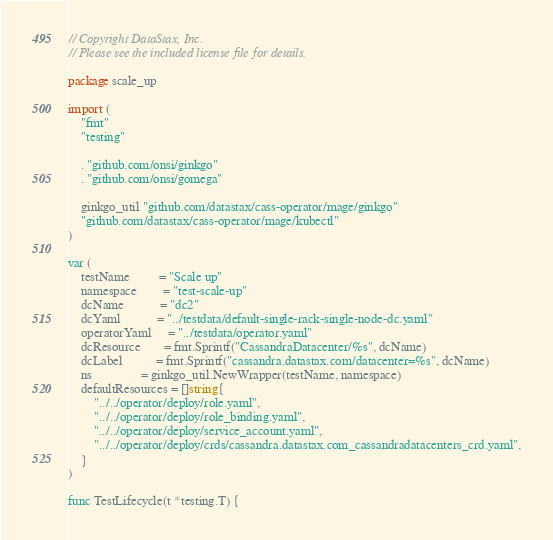Convert code to text. <code><loc_0><loc_0><loc_500><loc_500><_Go_>// Copyright DataStax, Inc.
// Please see the included license file for details.

package scale_up

import (
	"fmt"
	"testing"

	. "github.com/onsi/ginkgo"
	. "github.com/onsi/gomega"

	ginkgo_util "github.com/datastax/cass-operator/mage/ginkgo"
	"github.com/datastax/cass-operator/mage/kubectl"
)

var (
	testName         = "Scale up"
	namespace        = "test-scale-up"
	dcName           = "dc2"
	dcYaml           = "../testdata/default-single-rack-single-node-dc.yaml"
	operatorYaml     = "../testdata/operator.yaml"
	dcResource       = fmt.Sprintf("CassandraDatacenter/%s", dcName)
	dcLabel          = fmt.Sprintf("cassandra.datastax.com/datacenter=%s", dcName)
	ns               = ginkgo_util.NewWrapper(testName, namespace)
	defaultResources = []string{
		"../../operator/deploy/role.yaml",
		"../../operator/deploy/role_binding.yaml",
		"../../operator/deploy/service_account.yaml",
		"../../operator/deploy/crds/cassandra.datastax.com_cassandradatacenters_crd.yaml",
	}
)

func TestLifecycle(t *testing.T) {</code> 